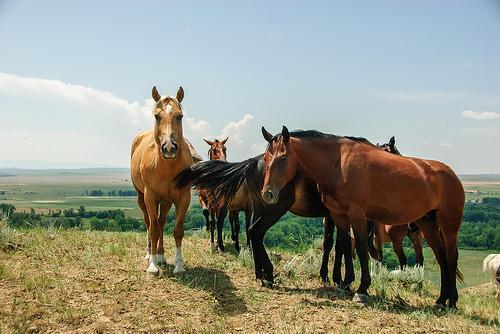How many ears can you see?
Give a very brief answer. 7. 